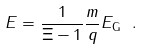Convert formula to latex. <formula><loc_0><loc_0><loc_500><loc_500>E = \frac { 1 } { \Xi - 1 } \frac { m } { q } E _ { \text {G} } \text { } .</formula> 